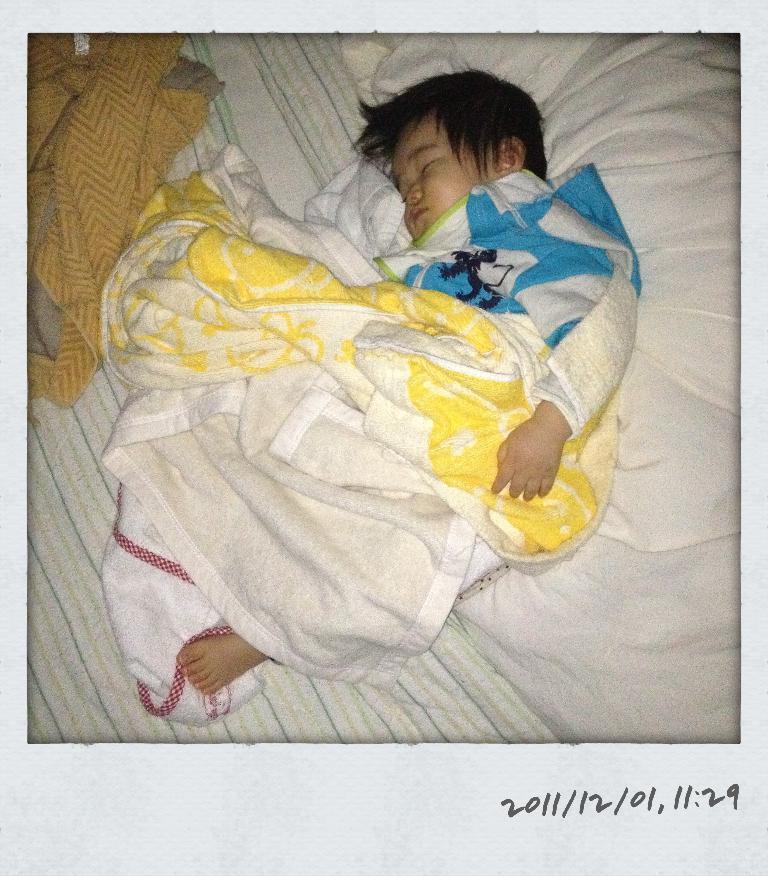In one or two sentences, can you explain what this image depicts? In this picture I can see a baby sleeping in the middle, there are clothes. In the bottom right hand side there is the text. 